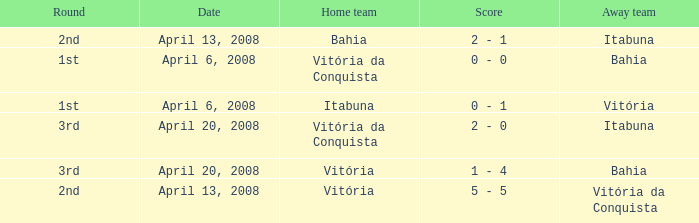What is the name of the home team on April 13, 2008 when Itabuna was the away team? Bahia. 